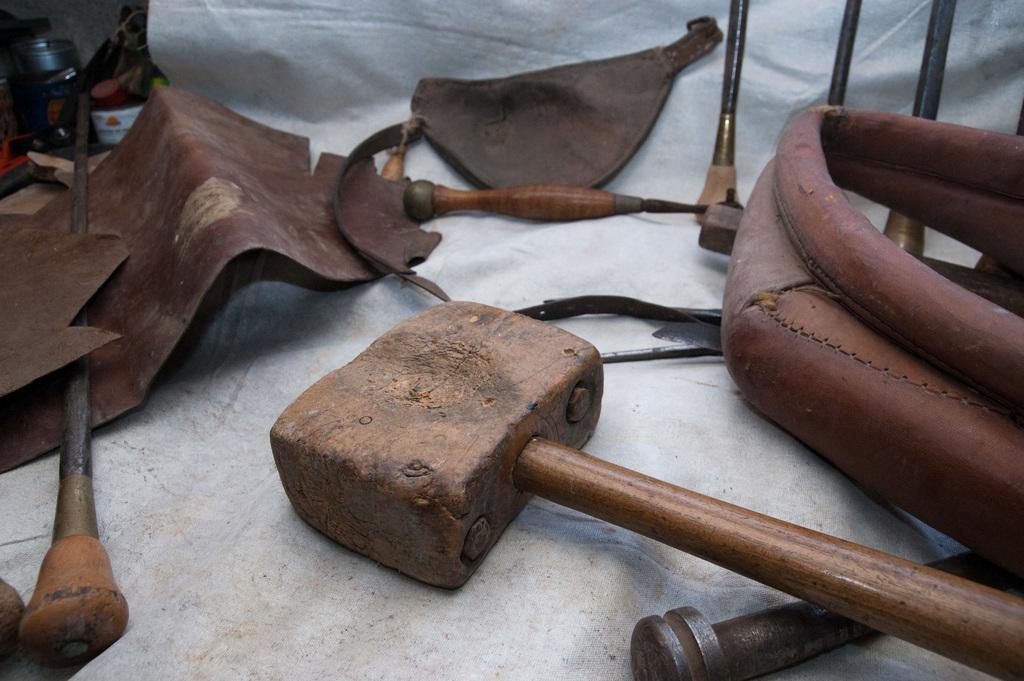Describe this image in one or two sentences. In this picture I can see few instruments and I can see few leather pieces and looks like a wooden hammer. 